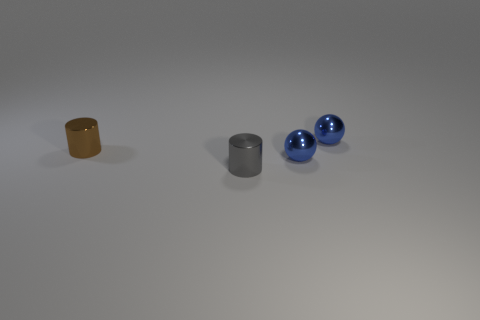Is the material of the small cylinder that is to the right of the tiny brown object the same as the tiny brown cylinder?
Your answer should be compact. Yes. Are there fewer blue spheres in front of the gray thing than metal objects?
Keep it short and to the point. Yes. Is there a blue thing made of the same material as the tiny gray cylinder?
Ensure brevity in your answer.  Yes. There is a brown thing; does it have the same size as the gray thing on the right side of the brown thing?
Keep it short and to the point. Yes. Are the gray object and the small brown cylinder made of the same material?
Your answer should be compact. Yes. There is a tiny brown metallic thing; what number of tiny gray metallic objects are right of it?
Provide a short and direct response. 1. What is the tiny thing that is both on the right side of the gray cylinder and in front of the brown metallic thing made of?
Provide a short and direct response. Metal. How many shiny balls have the same size as the brown metal object?
Provide a short and direct response. 2. There is a small metal sphere that is in front of the small metallic cylinder that is to the left of the small gray metal object; what color is it?
Offer a terse response. Blue. Are any tiny blue metal balls visible?
Your answer should be very brief. Yes. 